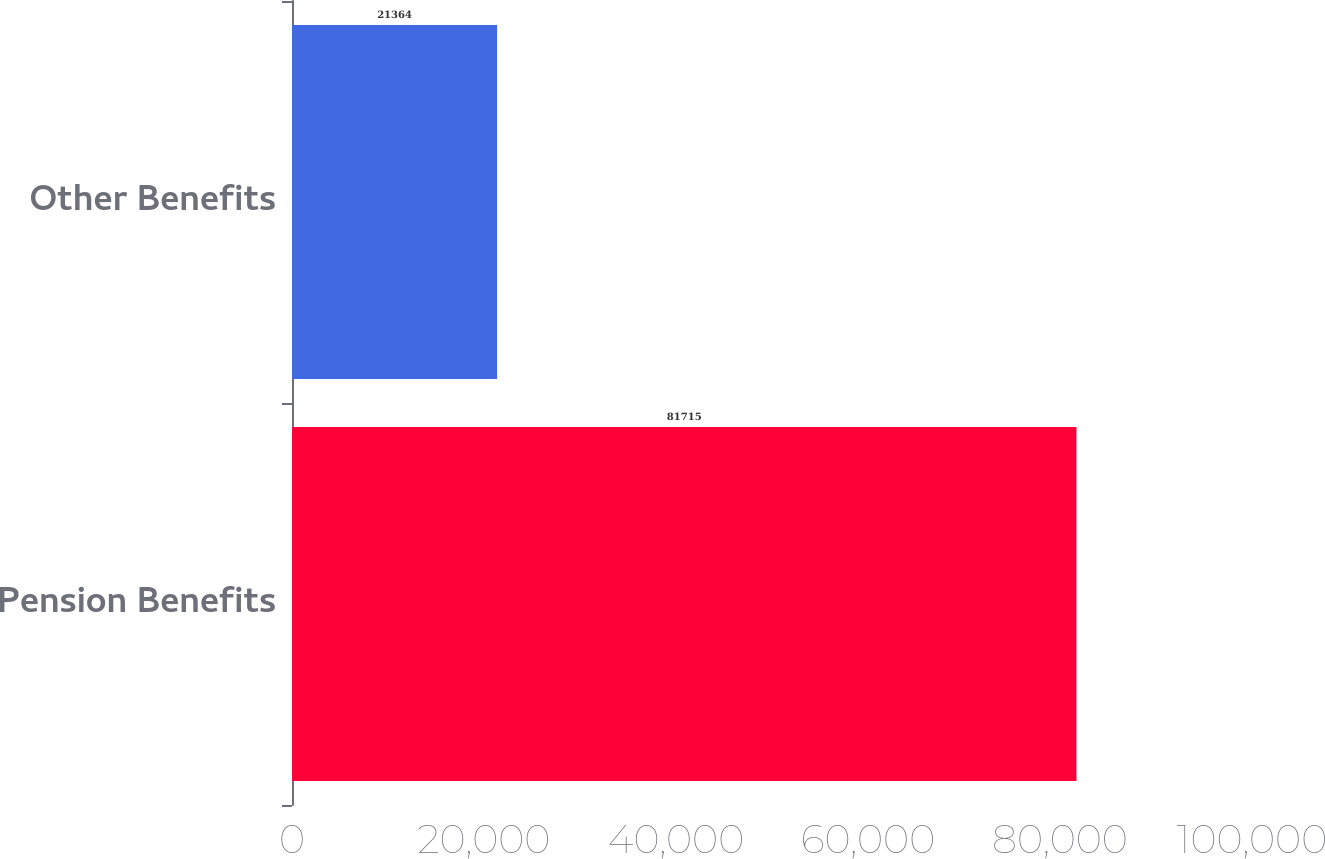Convert chart to OTSL. <chart><loc_0><loc_0><loc_500><loc_500><bar_chart><fcel>Pension Benefits<fcel>Other Benefits<nl><fcel>81715<fcel>21364<nl></chart> 